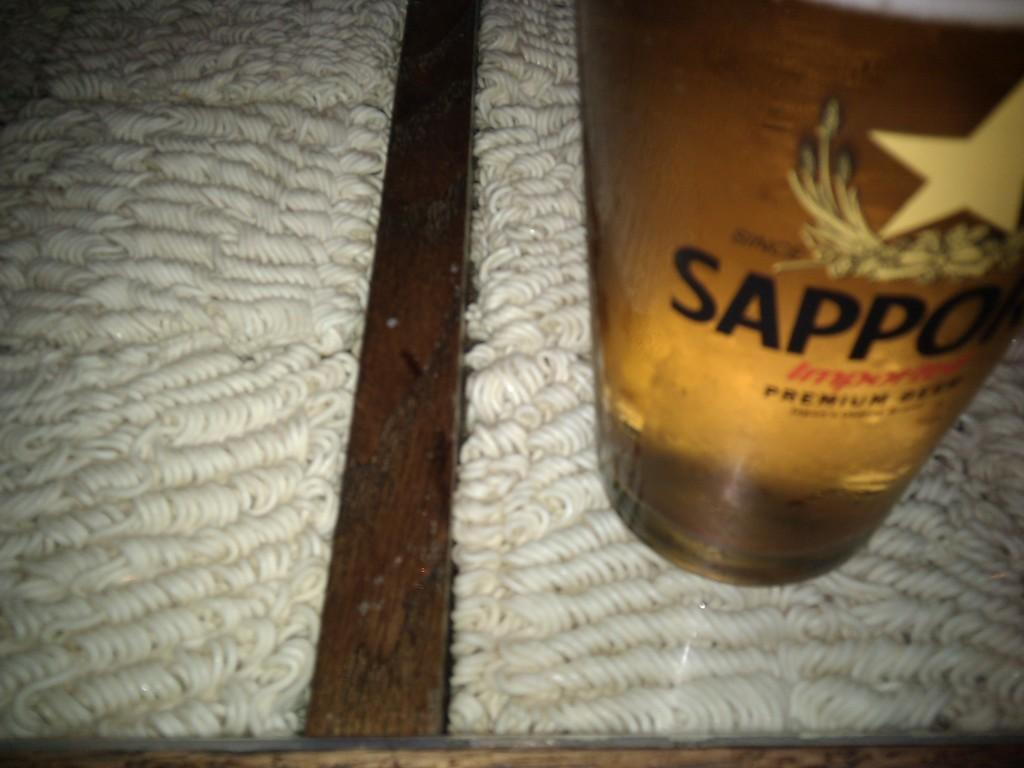Provide a one-sentence caption for the provided image. A bottle of Sapporo beer sits on a tan carpet. 